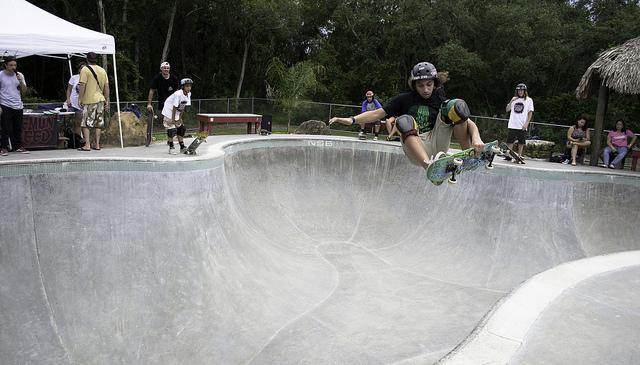What are they skateboarding in?
Quick response, please. Pool. Is there a tent nearby?
Concise answer only. Yes. Is the skater using wrist guards?
Give a very brief answer. No. 